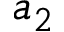Convert formula to latex. <formula><loc_0><loc_0><loc_500><loc_500>a _ { 2 }</formula> 